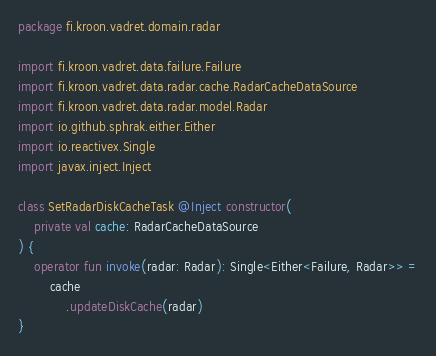Convert code to text. <code><loc_0><loc_0><loc_500><loc_500><_Kotlin_>package fi.kroon.vadret.domain.radar

import fi.kroon.vadret.data.failure.Failure
import fi.kroon.vadret.data.radar.cache.RadarCacheDataSource
import fi.kroon.vadret.data.radar.model.Radar
import io.github.sphrak.either.Either
import io.reactivex.Single
import javax.inject.Inject

class SetRadarDiskCacheTask @Inject constructor(
    private val cache: RadarCacheDataSource
) {
    operator fun invoke(radar: Radar): Single<Either<Failure, Radar>> =
        cache
            .updateDiskCache(radar)
}</code> 